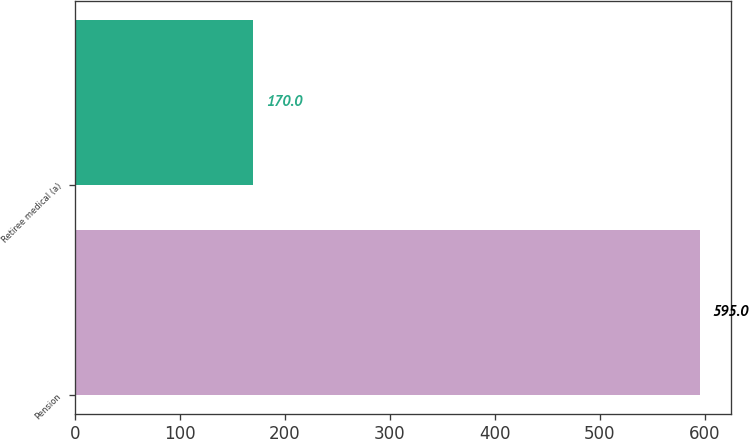<chart> <loc_0><loc_0><loc_500><loc_500><bar_chart><fcel>Pension<fcel>Retiree medical (a)<nl><fcel>595<fcel>170<nl></chart> 